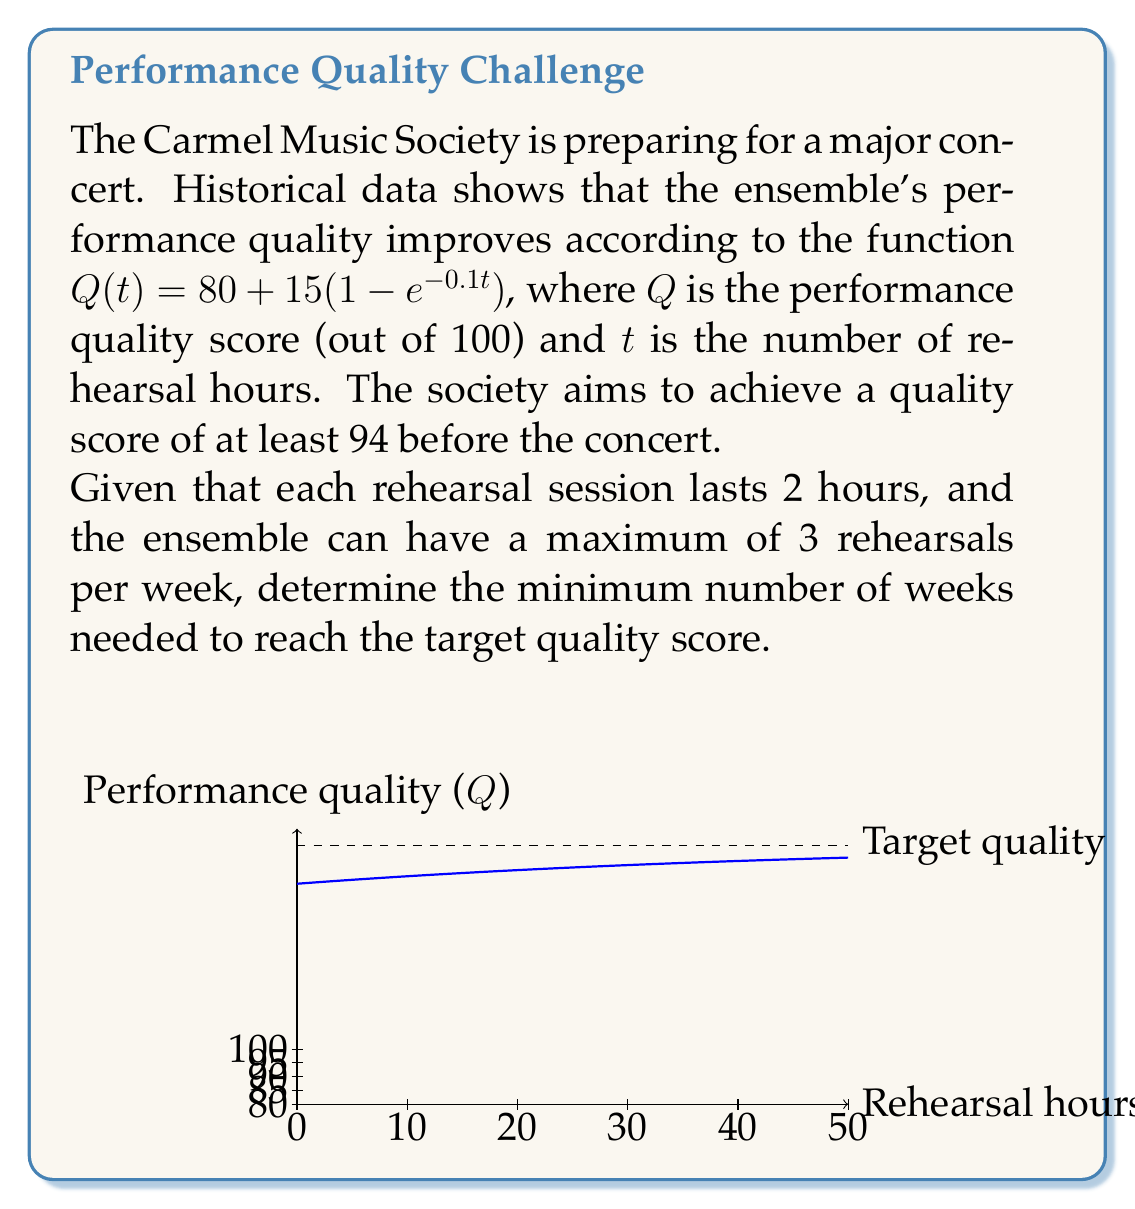What is the answer to this math problem? Let's approach this step-by-step:

1) We need to find $t$ when $Q(t) = 94$. Let's set up the equation:

   $94 = 80 + 15(1 - e^{-0.1t})$

2) Solve for $t$:
   $14 = 15(1 - e^{-0.1t})$
   $\frac{14}{15} = 1 - e^{-0.1t}$
   $e^{-0.1t} = 1 - \frac{14}{15} = \frac{1}{15}$

3) Take natural log of both sides:
   $-0.1t = \ln(\frac{1}{15})$
   $t = -10 \ln(\frac{1}{15}) \approx 27.0$ hours

4) Now, we need to convert this to weeks:
   - Each rehearsal is 2 hours
   - Maximum 3 rehearsals per week
   - Maximum rehearsal time per week = $2 * 3 = 6$ hours

5) Number of weeks = $\lceil \frac{27.0}{6} \rceil = 5$ weeks

   We use the ceiling function because we can't have a fractional number of weeks.
Answer: 5 weeks 